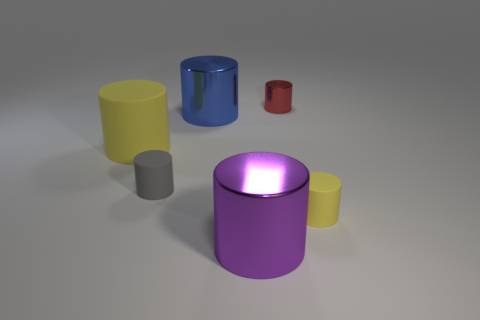Subtract all tiny red shiny cylinders. How many cylinders are left? 5 Add 2 small matte things. How many objects exist? 8 Subtract all brown cubes. How many yellow cylinders are left? 2 Subtract all gray cylinders. How many cylinders are left? 5 Add 2 blue metal objects. How many blue metal objects exist? 3 Subtract 0 cyan balls. How many objects are left? 6 Subtract all purple cylinders. Subtract all green balls. How many cylinders are left? 5 Subtract all big blue cylinders. Subtract all yellow cylinders. How many objects are left? 3 Add 5 yellow things. How many yellow things are left? 7 